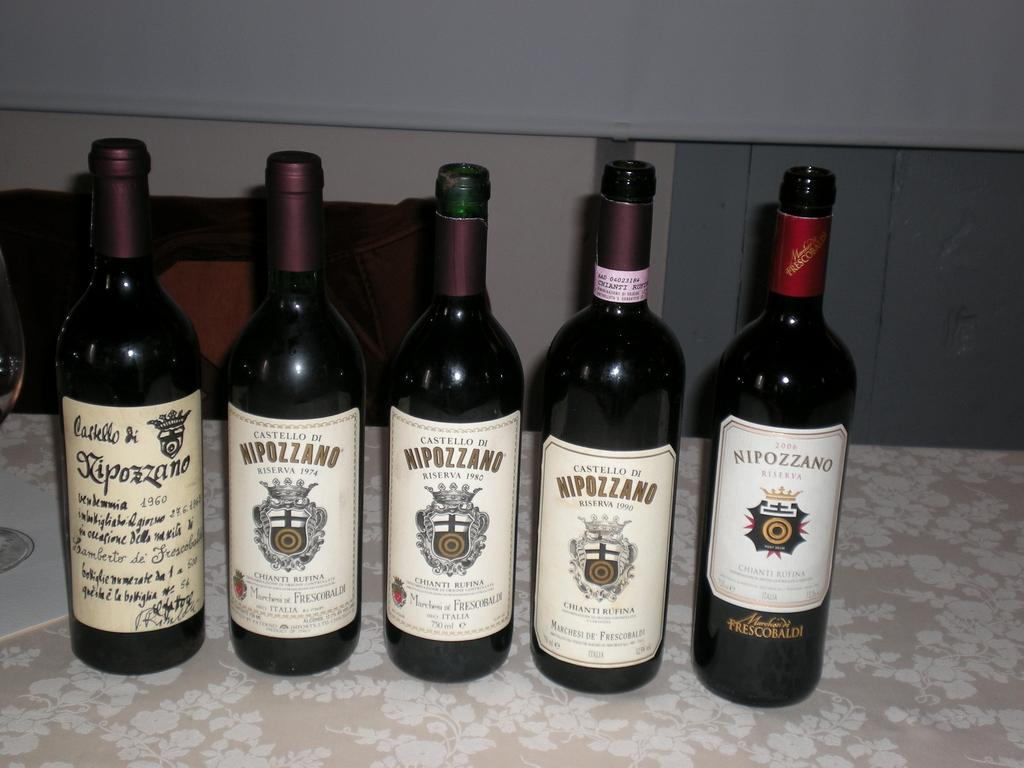<image>
Summarize the visual content of the image. the word Nipozzano that is on a bottle 